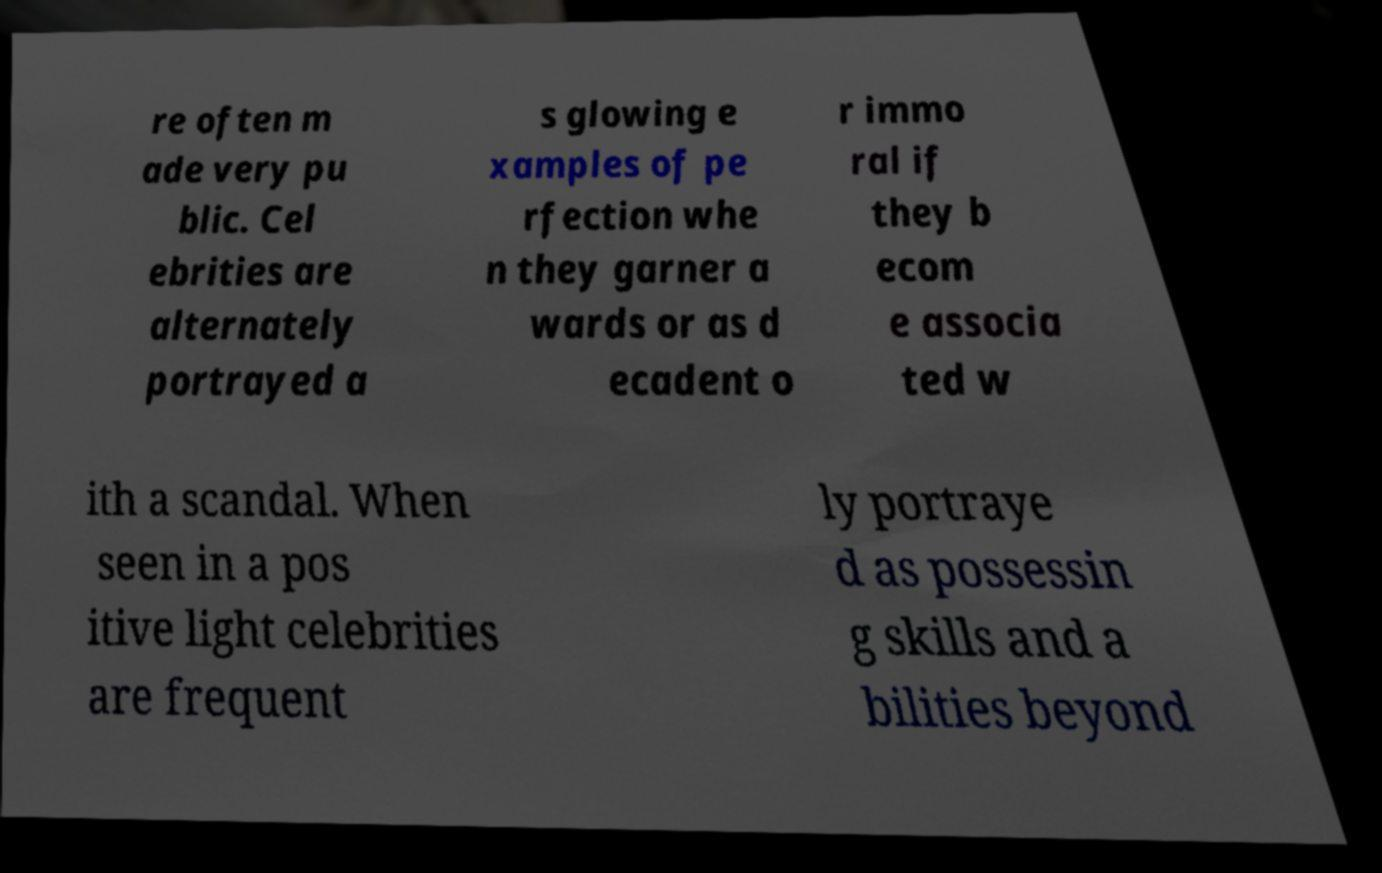Please identify and transcribe the text found in this image. re often m ade very pu blic. Cel ebrities are alternately portrayed a s glowing e xamples of pe rfection whe n they garner a wards or as d ecadent o r immo ral if they b ecom e associa ted w ith a scandal. When seen in a pos itive light celebrities are frequent ly portraye d as possessin g skills and a bilities beyond 